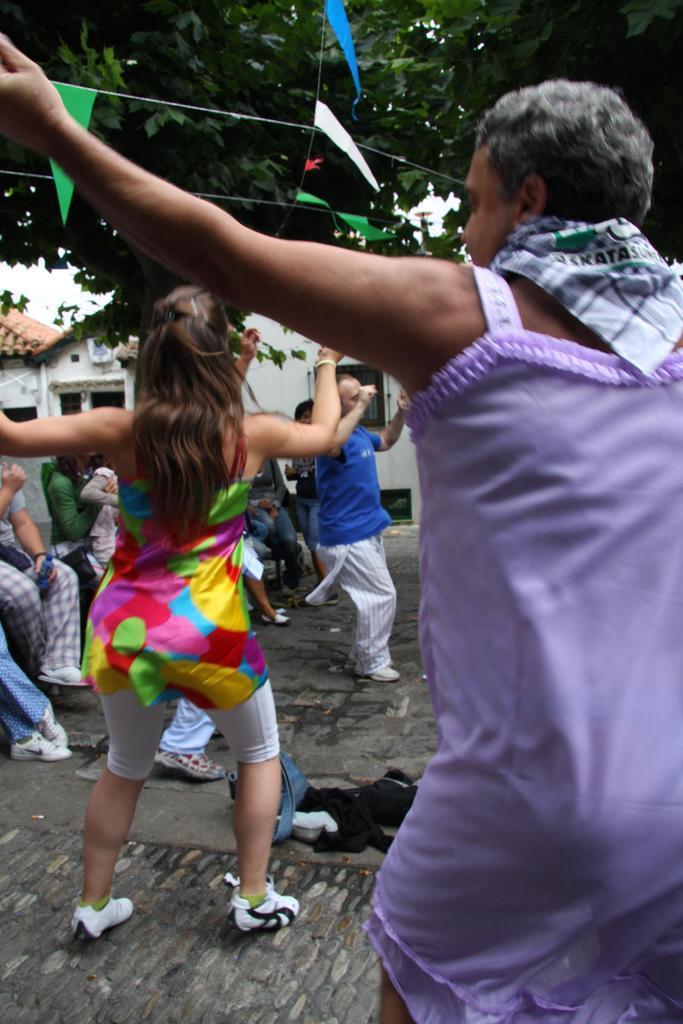Describe this image in one or two sentences. In this image I can see there are three persons performing a dance and some persons sitting on chair on left side and I can see a rope in the top and I can see colorful paper attached and there is a tree in the top , in the middle there are houses visible. 